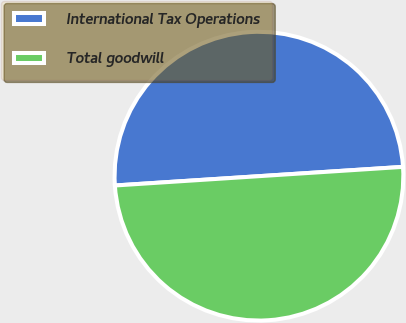Convert chart. <chart><loc_0><loc_0><loc_500><loc_500><pie_chart><fcel>International Tax Operations<fcel>Total goodwill<nl><fcel>50.0%<fcel>50.0%<nl></chart> 